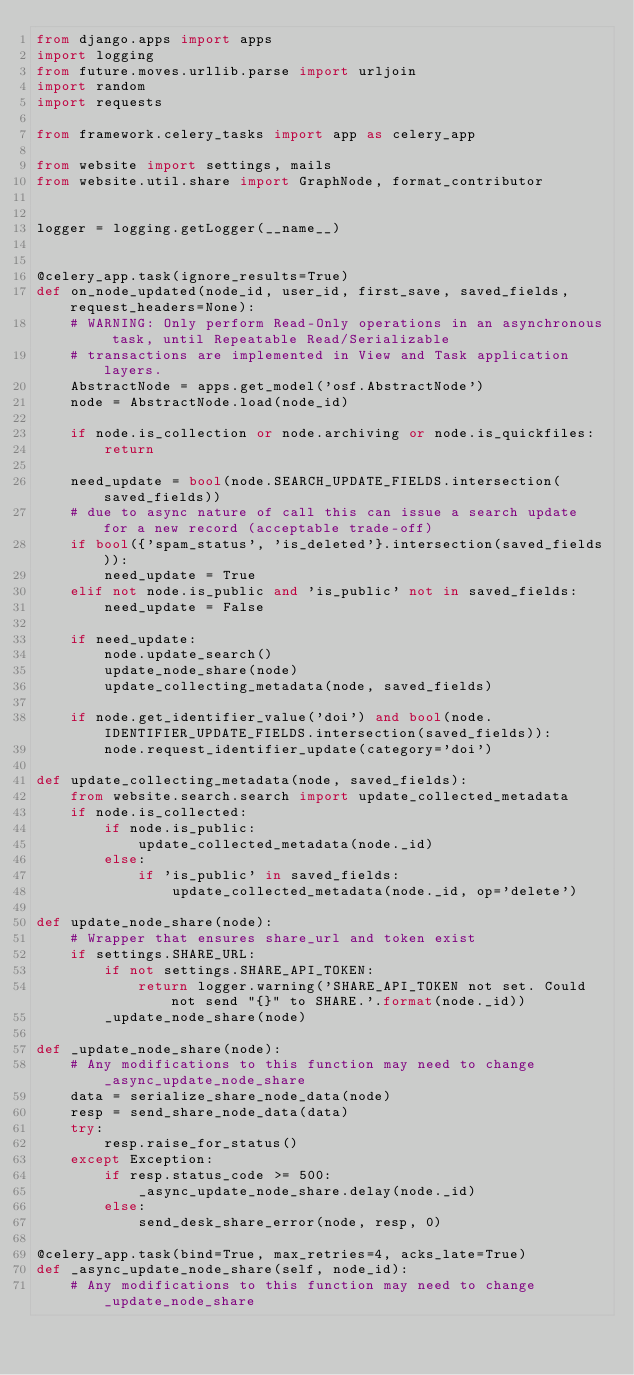<code> <loc_0><loc_0><loc_500><loc_500><_Python_>from django.apps import apps
import logging
from future.moves.urllib.parse import urljoin
import random
import requests

from framework.celery_tasks import app as celery_app

from website import settings, mails
from website.util.share import GraphNode, format_contributor


logger = logging.getLogger(__name__)


@celery_app.task(ignore_results=True)
def on_node_updated(node_id, user_id, first_save, saved_fields, request_headers=None):
    # WARNING: Only perform Read-Only operations in an asynchronous task, until Repeatable Read/Serializable
    # transactions are implemented in View and Task application layers.
    AbstractNode = apps.get_model('osf.AbstractNode')
    node = AbstractNode.load(node_id)

    if node.is_collection or node.archiving or node.is_quickfiles:
        return

    need_update = bool(node.SEARCH_UPDATE_FIELDS.intersection(saved_fields))
    # due to async nature of call this can issue a search update for a new record (acceptable trade-off)
    if bool({'spam_status', 'is_deleted'}.intersection(saved_fields)):
        need_update = True
    elif not node.is_public and 'is_public' not in saved_fields:
        need_update = False

    if need_update:
        node.update_search()
        update_node_share(node)
        update_collecting_metadata(node, saved_fields)

    if node.get_identifier_value('doi') and bool(node.IDENTIFIER_UPDATE_FIELDS.intersection(saved_fields)):
        node.request_identifier_update(category='doi')

def update_collecting_metadata(node, saved_fields):
    from website.search.search import update_collected_metadata
    if node.is_collected:
        if node.is_public:
            update_collected_metadata(node._id)
        else:
            if 'is_public' in saved_fields:
                update_collected_metadata(node._id, op='delete')

def update_node_share(node):
    # Wrapper that ensures share_url and token exist
    if settings.SHARE_URL:
        if not settings.SHARE_API_TOKEN:
            return logger.warning('SHARE_API_TOKEN not set. Could not send "{}" to SHARE.'.format(node._id))
        _update_node_share(node)

def _update_node_share(node):
    # Any modifications to this function may need to change _async_update_node_share
    data = serialize_share_node_data(node)
    resp = send_share_node_data(data)
    try:
        resp.raise_for_status()
    except Exception:
        if resp.status_code >= 500:
            _async_update_node_share.delay(node._id)
        else:
            send_desk_share_error(node, resp, 0)

@celery_app.task(bind=True, max_retries=4, acks_late=True)
def _async_update_node_share(self, node_id):
    # Any modifications to this function may need to change _update_node_share</code> 